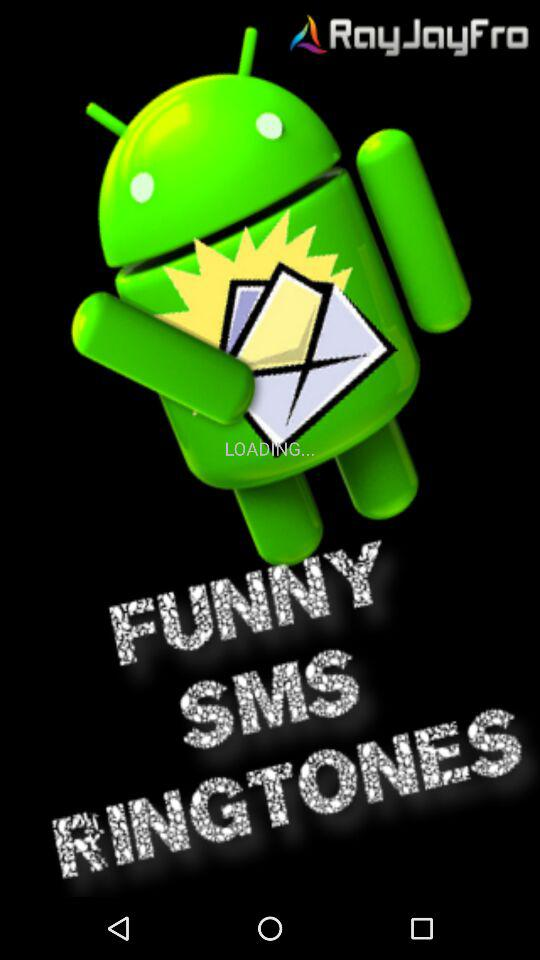What is the name of the application? The name of the application is "FUNNY SMS RINGTONES". 